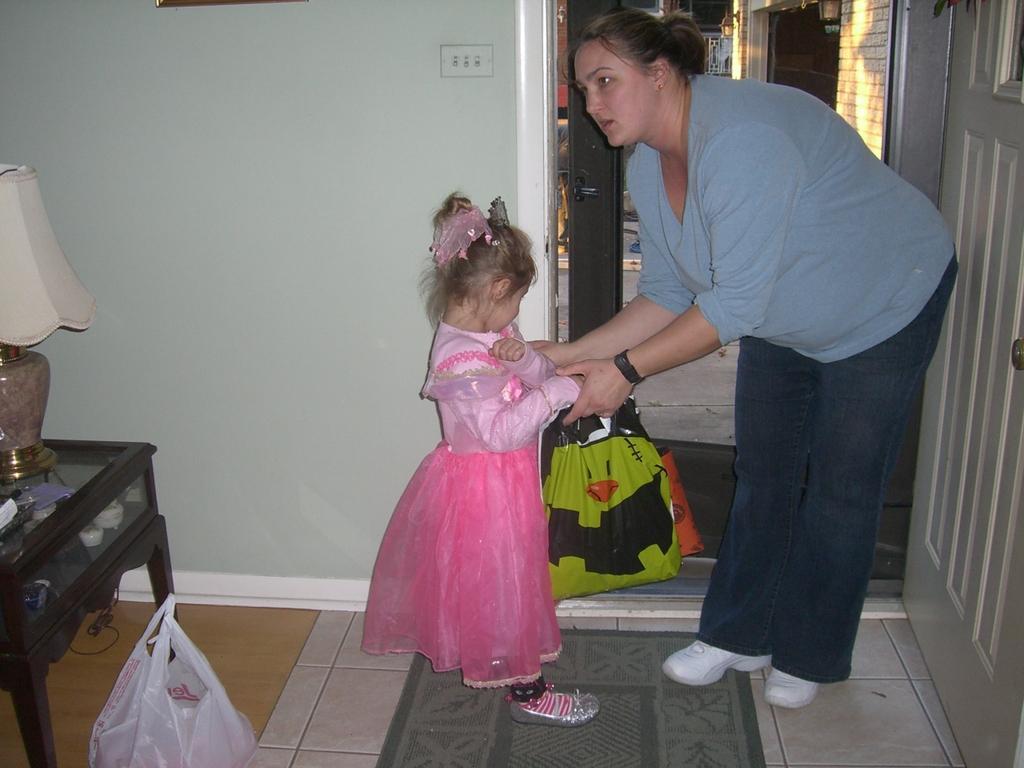Can you describe this image briefly? in the picture a woman and a girl standing opposite to each other the woman carrying carry bag 